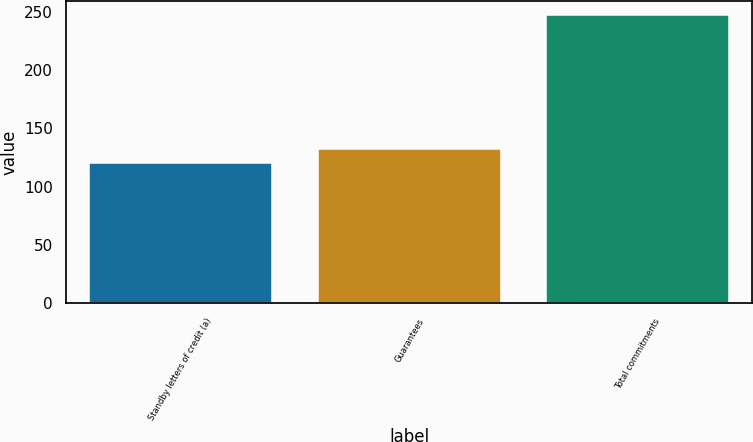<chart> <loc_0><loc_0><loc_500><loc_500><bar_chart><fcel>Standby letters of credit (a)<fcel>Guarantees<fcel>Total commitments<nl><fcel>120<fcel>132.7<fcel>247<nl></chart> 